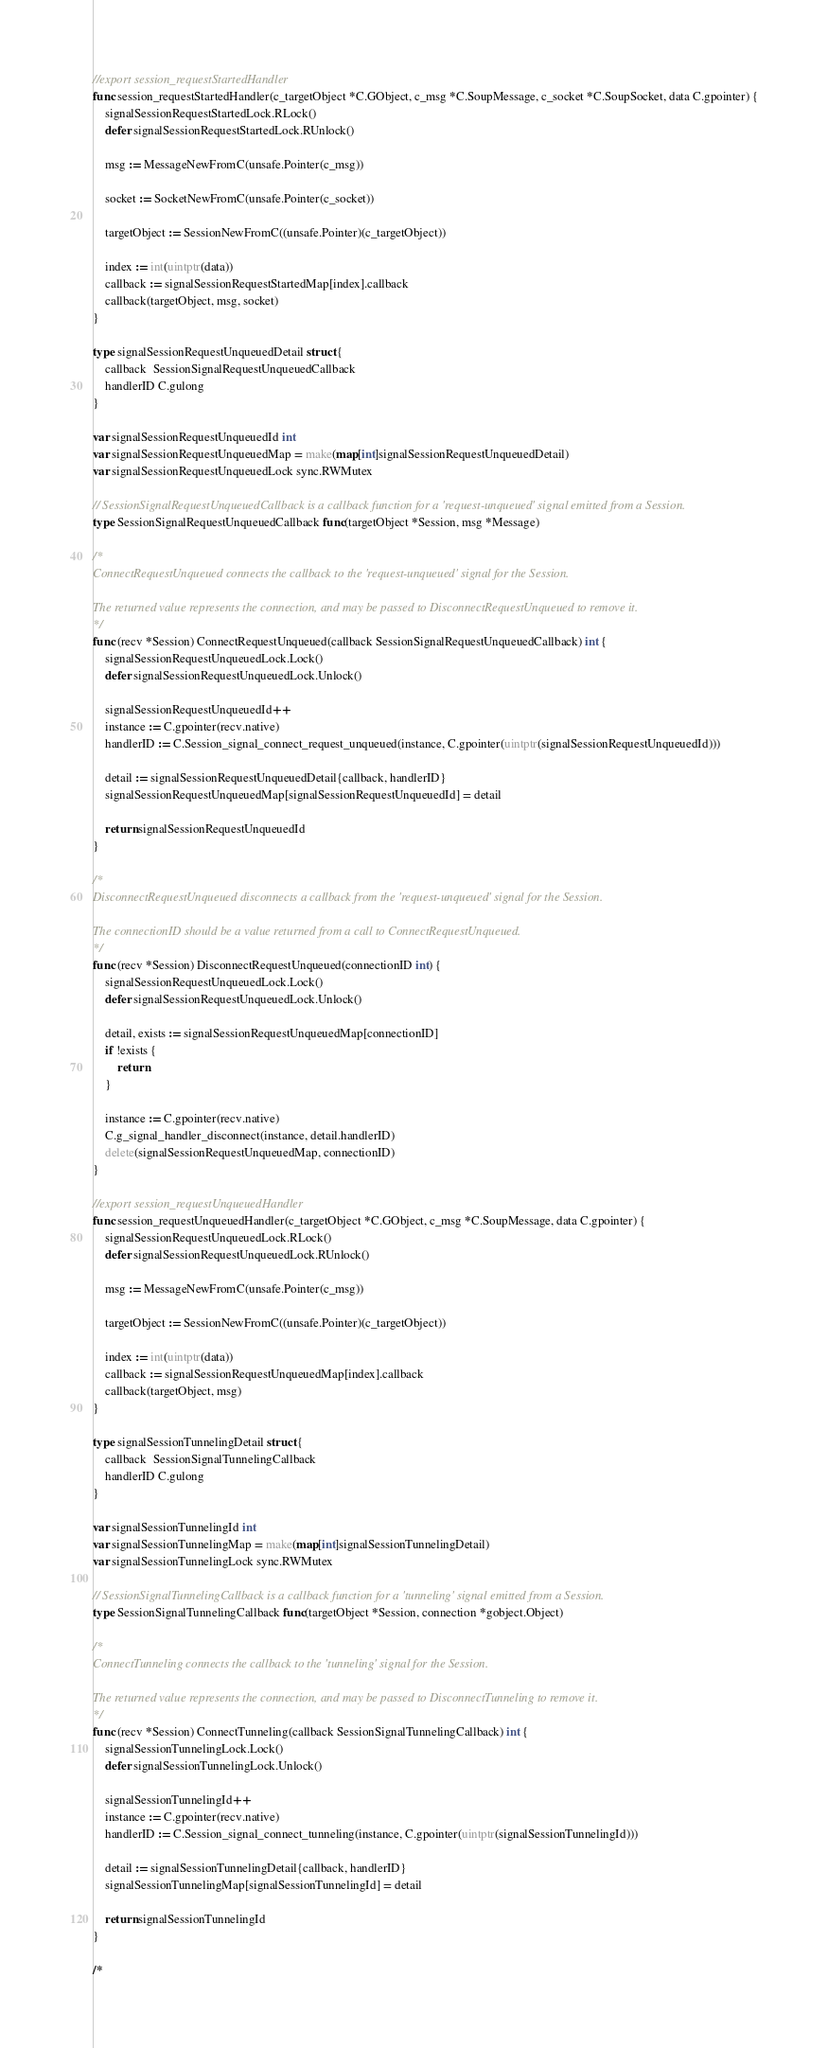<code> <loc_0><loc_0><loc_500><loc_500><_Go_>
//export session_requestStartedHandler
func session_requestStartedHandler(c_targetObject *C.GObject, c_msg *C.SoupMessage, c_socket *C.SoupSocket, data C.gpointer) {
	signalSessionRequestStartedLock.RLock()
	defer signalSessionRequestStartedLock.RUnlock()

	msg := MessageNewFromC(unsafe.Pointer(c_msg))

	socket := SocketNewFromC(unsafe.Pointer(c_socket))

	targetObject := SessionNewFromC((unsafe.Pointer)(c_targetObject))

	index := int(uintptr(data))
	callback := signalSessionRequestStartedMap[index].callback
	callback(targetObject, msg, socket)
}

type signalSessionRequestUnqueuedDetail struct {
	callback  SessionSignalRequestUnqueuedCallback
	handlerID C.gulong
}

var signalSessionRequestUnqueuedId int
var signalSessionRequestUnqueuedMap = make(map[int]signalSessionRequestUnqueuedDetail)
var signalSessionRequestUnqueuedLock sync.RWMutex

// SessionSignalRequestUnqueuedCallback is a callback function for a 'request-unqueued' signal emitted from a Session.
type SessionSignalRequestUnqueuedCallback func(targetObject *Session, msg *Message)

/*
ConnectRequestUnqueued connects the callback to the 'request-unqueued' signal for the Session.

The returned value represents the connection, and may be passed to DisconnectRequestUnqueued to remove it.
*/
func (recv *Session) ConnectRequestUnqueued(callback SessionSignalRequestUnqueuedCallback) int {
	signalSessionRequestUnqueuedLock.Lock()
	defer signalSessionRequestUnqueuedLock.Unlock()

	signalSessionRequestUnqueuedId++
	instance := C.gpointer(recv.native)
	handlerID := C.Session_signal_connect_request_unqueued(instance, C.gpointer(uintptr(signalSessionRequestUnqueuedId)))

	detail := signalSessionRequestUnqueuedDetail{callback, handlerID}
	signalSessionRequestUnqueuedMap[signalSessionRequestUnqueuedId] = detail

	return signalSessionRequestUnqueuedId
}

/*
DisconnectRequestUnqueued disconnects a callback from the 'request-unqueued' signal for the Session.

The connectionID should be a value returned from a call to ConnectRequestUnqueued.
*/
func (recv *Session) DisconnectRequestUnqueued(connectionID int) {
	signalSessionRequestUnqueuedLock.Lock()
	defer signalSessionRequestUnqueuedLock.Unlock()

	detail, exists := signalSessionRequestUnqueuedMap[connectionID]
	if !exists {
		return
	}

	instance := C.gpointer(recv.native)
	C.g_signal_handler_disconnect(instance, detail.handlerID)
	delete(signalSessionRequestUnqueuedMap, connectionID)
}

//export session_requestUnqueuedHandler
func session_requestUnqueuedHandler(c_targetObject *C.GObject, c_msg *C.SoupMessage, data C.gpointer) {
	signalSessionRequestUnqueuedLock.RLock()
	defer signalSessionRequestUnqueuedLock.RUnlock()

	msg := MessageNewFromC(unsafe.Pointer(c_msg))

	targetObject := SessionNewFromC((unsafe.Pointer)(c_targetObject))

	index := int(uintptr(data))
	callback := signalSessionRequestUnqueuedMap[index].callback
	callback(targetObject, msg)
}

type signalSessionTunnelingDetail struct {
	callback  SessionSignalTunnelingCallback
	handlerID C.gulong
}

var signalSessionTunnelingId int
var signalSessionTunnelingMap = make(map[int]signalSessionTunnelingDetail)
var signalSessionTunnelingLock sync.RWMutex

// SessionSignalTunnelingCallback is a callback function for a 'tunneling' signal emitted from a Session.
type SessionSignalTunnelingCallback func(targetObject *Session, connection *gobject.Object)

/*
ConnectTunneling connects the callback to the 'tunneling' signal for the Session.

The returned value represents the connection, and may be passed to DisconnectTunneling to remove it.
*/
func (recv *Session) ConnectTunneling(callback SessionSignalTunnelingCallback) int {
	signalSessionTunnelingLock.Lock()
	defer signalSessionTunnelingLock.Unlock()

	signalSessionTunnelingId++
	instance := C.gpointer(recv.native)
	handlerID := C.Session_signal_connect_tunneling(instance, C.gpointer(uintptr(signalSessionTunnelingId)))

	detail := signalSessionTunnelingDetail{callback, handlerID}
	signalSessionTunnelingMap[signalSessionTunnelingId] = detail

	return signalSessionTunnelingId
}

/*</code> 